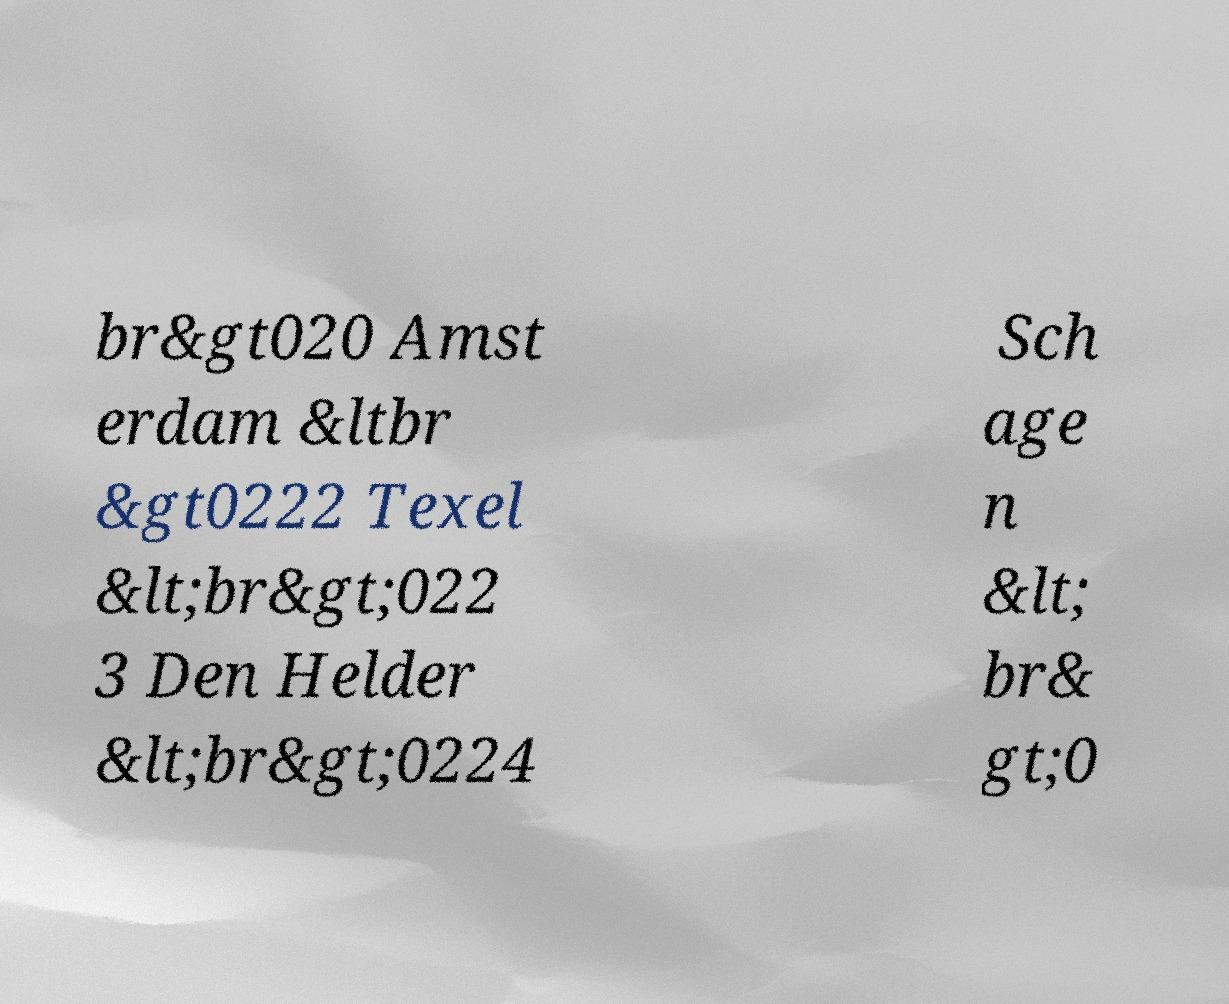Can you read and provide the text displayed in the image?This photo seems to have some interesting text. Can you extract and type it out for me? br&gt020 Amst erdam &ltbr &gt0222 Texel &lt;br&gt;022 3 Den Helder &lt;br&gt;0224 Sch age n &lt; br& gt;0 